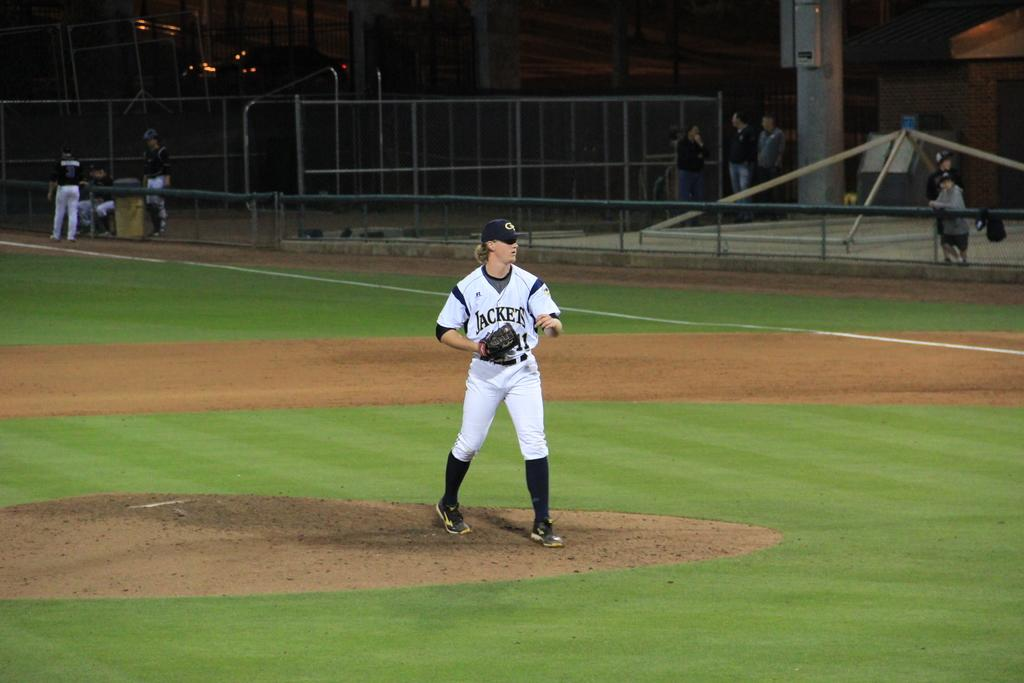<image>
Render a clear and concise summary of the photo. Jackets is shown as the team name of the player on the mound. 